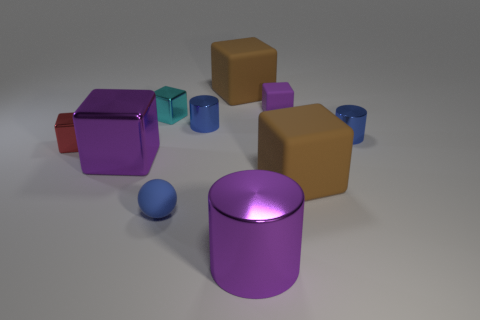Are there any other things that have the same size as the purple rubber object?
Give a very brief answer. Yes. Is the number of big brown objects less than the number of cylinders?
Ensure brevity in your answer.  Yes. Is the size of the shiny cube that is in front of the red metallic cube the same as the purple cylinder to the right of the tiny cyan block?
Offer a terse response. Yes. How many objects are small gray objects or big brown things?
Your answer should be very brief. 2. What size is the purple shiny thing that is behind the tiny blue sphere?
Offer a terse response. Large. How many shiny objects are on the right side of the large brown cube that is on the left side of the purple metal thing that is in front of the rubber ball?
Provide a short and direct response. 2. Is the color of the large shiny block the same as the big metallic cylinder?
Provide a succinct answer. Yes. How many things are both to the right of the tiny purple cube and behind the big purple metallic block?
Your response must be concise. 1. What shape is the tiny rubber object on the left side of the purple rubber object?
Make the answer very short. Sphere. Are there fewer big purple shiny cylinders behind the big purple cube than large purple objects that are to the left of the big cylinder?
Offer a very short reply. Yes. 